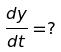Convert formula to latex. <formula><loc_0><loc_0><loc_500><loc_500>\frac { d y } { d t } = ?</formula> 